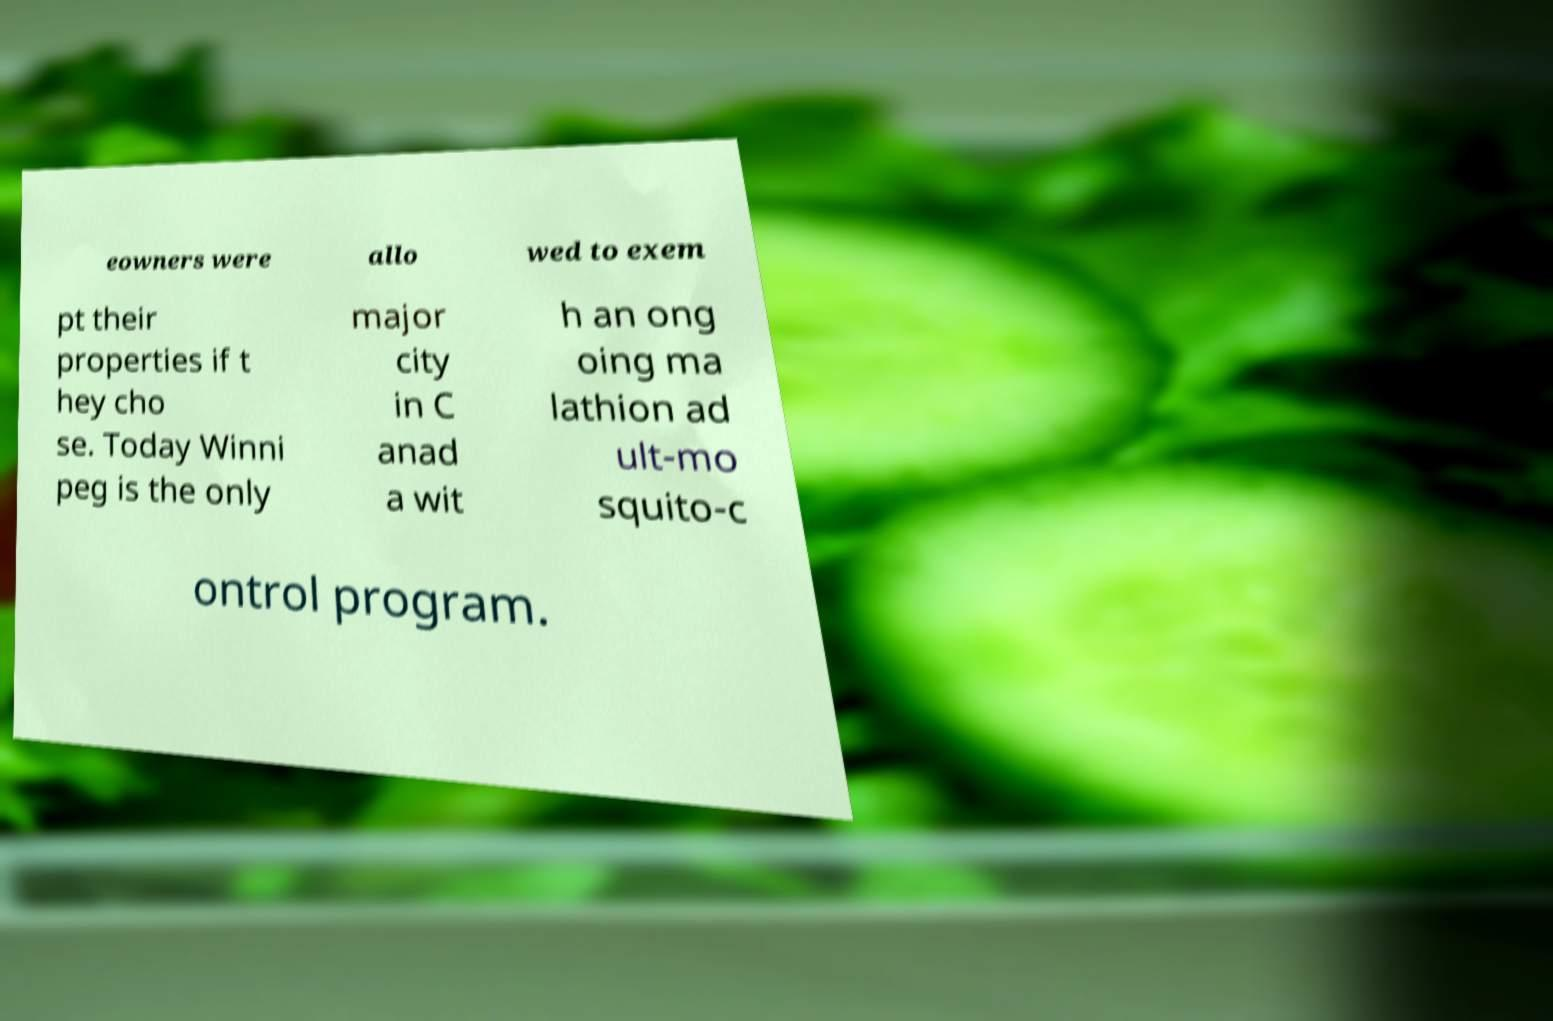Can you read and provide the text displayed in the image?This photo seems to have some interesting text. Can you extract and type it out for me? eowners were allo wed to exem pt their properties if t hey cho se. Today Winni peg is the only major city in C anad a wit h an ong oing ma lathion ad ult-mo squito-c ontrol program. 